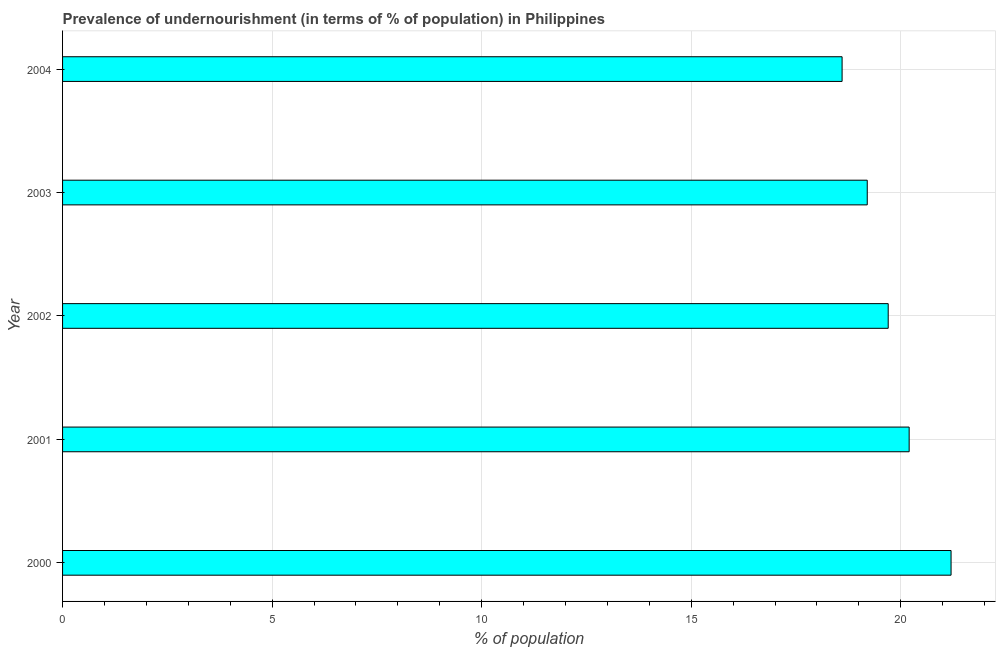Does the graph contain grids?
Your answer should be very brief. Yes. What is the title of the graph?
Provide a succinct answer. Prevalence of undernourishment (in terms of % of population) in Philippines. What is the label or title of the X-axis?
Provide a succinct answer. % of population. What is the percentage of undernourished population in 2001?
Keep it short and to the point. 20.2. Across all years, what is the maximum percentage of undernourished population?
Make the answer very short. 21.2. Across all years, what is the minimum percentage of undernourished population?
Give a very brief answer. 18.6. In which year was the percentage of undernourished population maximum?
Provide a succinct answer. 2000. What is the sum of the percentage of undernourished population?
Keep it short and to the point. 98.9. What is the average percentage of undernourished population per year?
Give a very brief answer. 19.78. In how many years, is the percentage of undernourished population greater than 21 %?
Your answer should be very brief. 1. Do a majority of the years between 2003 and 2000 (inclusive) have percentage of undernourished population greater than 9 %?
Offer a very short reply. Yes. What is the ratio of the percentage of undernourished population in 2003 to that in 2004?
Make the answer very short. 1.03. Is the percentage of undernourished population in 2000 less than that in 2003?
Ensure brevity in your answer.  No. Is the difference between the percentage of undernourished population in 2000 and 2003 greater than the difference between any two years?
Your answer should be very brief. No. What is the difference between the highest and the second highest percentage of undernourished population?
Offer a very short reply. 1. What is the difference between the highest and the lowest percentage of undernourished population?
Provide a short and direct response. 2.6. In how many years, is the percentage of undernourished population greater than the average percentage of undernourished population taken over all years?
Offer a terse response. 2. How many years are there in the graph?
Keep it short and to the point. 5. What is the % of population of 2000?
Your answer should be compact. 21.2. What is the % of population in 2001?
Make the answer very short. 20.2. What is the % of population of 2002?
Give a very brief answer. 19.7. What is the % of population in 2004?
Your answer should be very brief. 18.6. What is the difference between the % of population in 2000 and 2001?
Make the answer very short. 1. What is the difference between the % of population in 2000 and 2003?
Ensure brevity in your answer.  2. What is the difference between the % of population in 2001 and 2002?
Ensure brevity in your answer.  0.5. What is the difference between the % of population in 2001 and 2004?
Provide a short and direct response. 1.6. What is the difference between the % of population in 2002 and 2003?
Your answer should be very brief. 0.5. What is the difference between the % of population in 2002 and 2004?
Offer a terse response. 1.1. What is the ratio of the % of population in 2000 to that in 2001?
Provide a succinct answer. 1.05. What is the ratio of the % of population in 2000 to that in 2002?
Ensure brevity in your answer.  1.08. What is the ratio of the % of population in 2000 to that in 2003?
Your answer should be compact. 1.1. What is the ratio of the % of population in 2000 to that in 2004?
Give a very brief answer. 1.14. What is the ratio of the % of population in 2001 to that in 2002?
Your answer should be compact. 1.02. What is the ratio of the % of population in 2001 to that in 2003?
Your answer should be very brief. 1.05. What is the ratio of the % of population in 2001 to that in 2004?
Offer a very short reply. 1.09. What is the ratio of the % of population in 2002 to that in 2004?
Give a very brief answer. 1.06. What is the ratio of the % of population in 2003 to that in 2004?
Your answer should be compact. 1.03. 